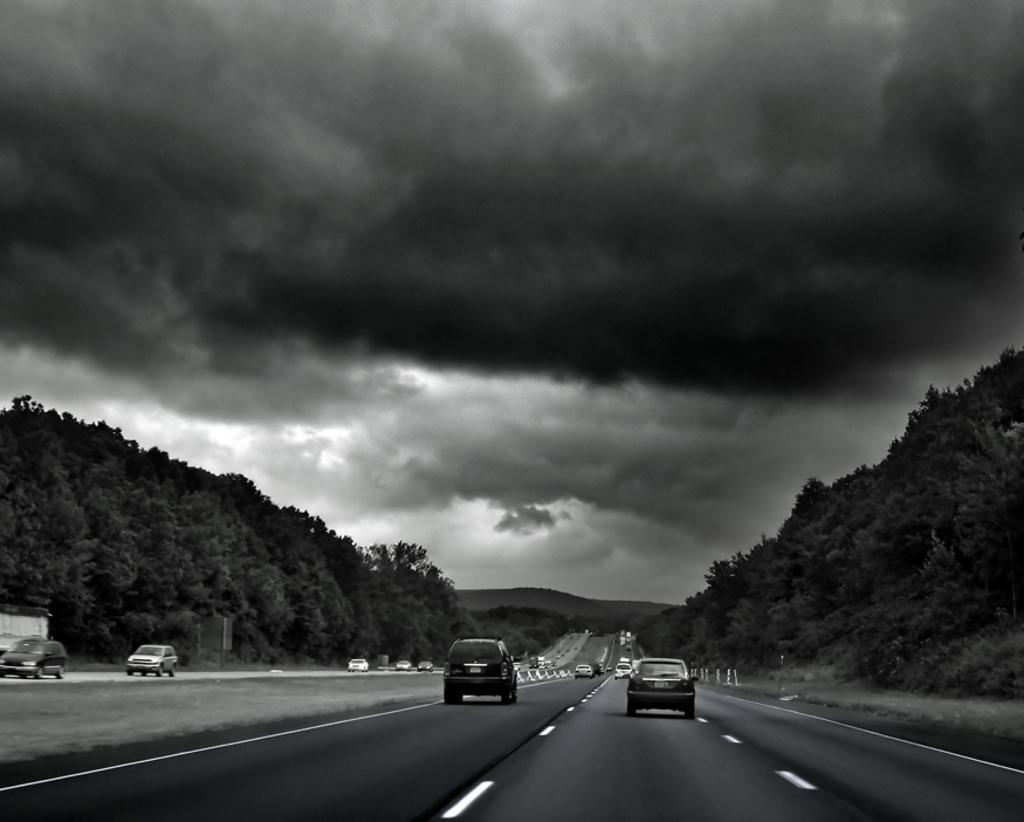In one or two sentences, can you explain what this image depicts? In this black and white image there are few vehicles moving on the road. On the right and left side of the image there are trees. In the background there are mountains and the sky. 